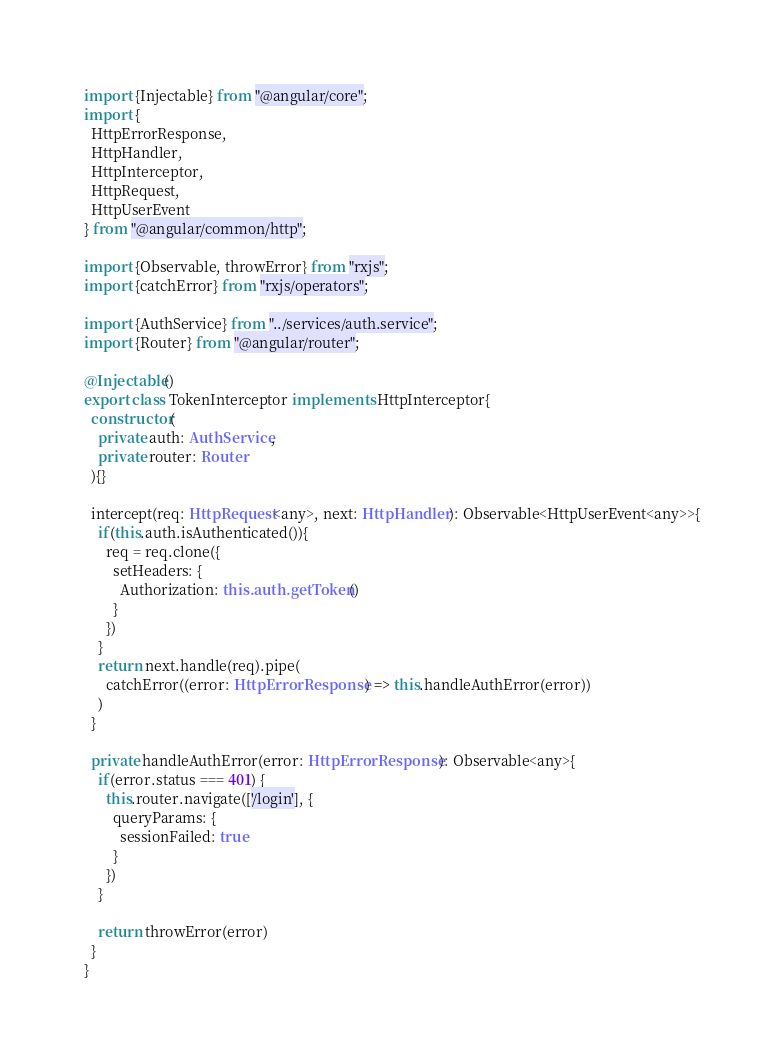<code> <loc_0><loc_0><loc_500><loc_500><_TypeScript_>import {Injectable} from "@angular/core";
import {
  HttpErrorResponse,
  HttpHandler,
  HttpInterceptor,
  HttpRequest,
  HttpUserEvent
} from "@angular/common/http";

import {Observable, throwError} from "rxjs";
import {catchError} from "rxjs/operators";

import {AuthService} from "../services/auth.service";
import {Router} from "@angular/router";

@Injectable()
export class TokenInterceptor implements HttpInterceptor{
  constructor(
    private auth: AuthService,
    private router: Router
  ){}

  intercept(req: HttpRequest<any>, next: HttpHandler): Observable<HttpUserEvent<any>>{
    if(this.auth.isAuthenticated()){
      req = req.clone({
        setHeaders: {
          Authorization: this.auth.getToken()
        }
      })
    }
    return next.handle(req).pipe(
      catchError((error: HttpErrorResponse) => this.handleAuthError(error))
    )
  }

  private handleAuthError(error: HttpErrorResponse): Observable<any>{
    if(error.status === 401) {
      this.router.navigate(['/login'], {
        queryParams: {
          sessionFailed: true
        }
      })
    }

    return throwError(error)
  }
}
</code> 